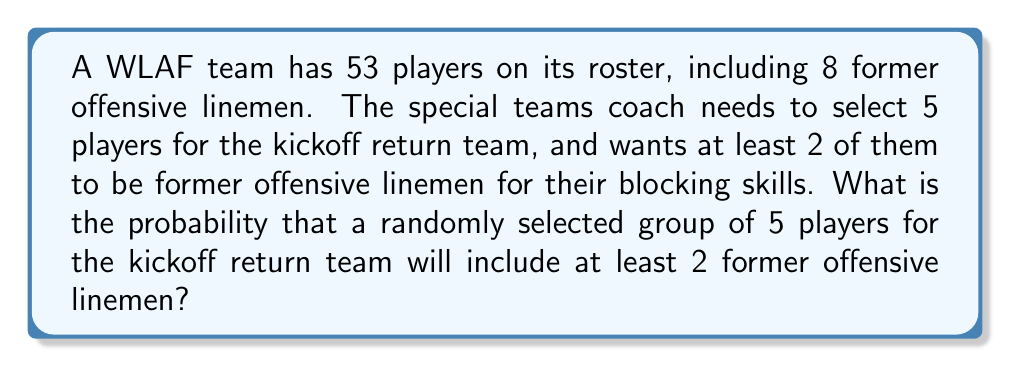Show me your answer to this math problem. Let's approach this step-by-step:

1) First, we need to calculate the total number of ways to select 5 players from 53. This is given by the combination formula:

   $$\binom{53}{5} = \frac{53!}{5!(53-5)!} = 2,869,685$$

2) Now, we need to calculate the number of ways to select at least 2 former offensive linemen. We can do this by considering three cases:
   a) Exactly 2 former offensive linemen and 3 other players
   b) Exactly 3 former offensive linemen and 2 other players
   c) Exactly 4 former offensive linemen and 1 other player
   d) All 5 are former offensive linemen

3) Let's calculate each case:
   a) $$\binom{8}{2} \times \binom{45}{3} = 28 \times 14,190 = 397,320$$
   b) $$\binom{8}{3} \times \binom{45}{2} = 56 \times 990 = 55,440$$
   c) $$\binom{8}{4} \times \binom{45}{1} = 70 \times 45 = 3,150$$
   d) $$\binom{8}{5} = 56$$

4) The total number of favorable outcomes is the sum of these cases:
   $$397,320 + 55,440 + 3,150 + 56 = 455,966$$

5) The probability is then:

   $$P(\text{at least 2 former OL}) = \frac{455,966}{2,869,685} \approx 0.1589$$
Answer: $\frac{455,966}{2,869,685} \approx 0.1589$ or about 15.89% 